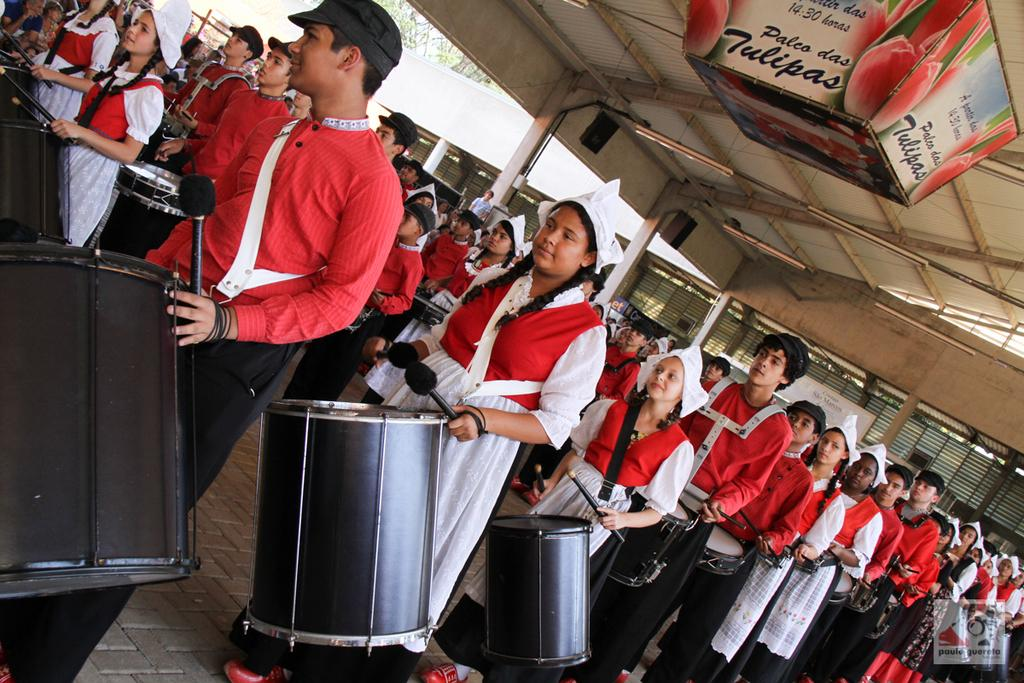What are the people in the image doing? The people in the image are standing and holding musical instruments. What are the people wearing on their heads? The people are wearing caps. What color are the dresses worn by the people in the image? The people are wearing red-colored dresses. What type of yak can be seen in the image? There is no yak present in the image; it features people holding musical instruments and wearing caps and red-colored dresses. 